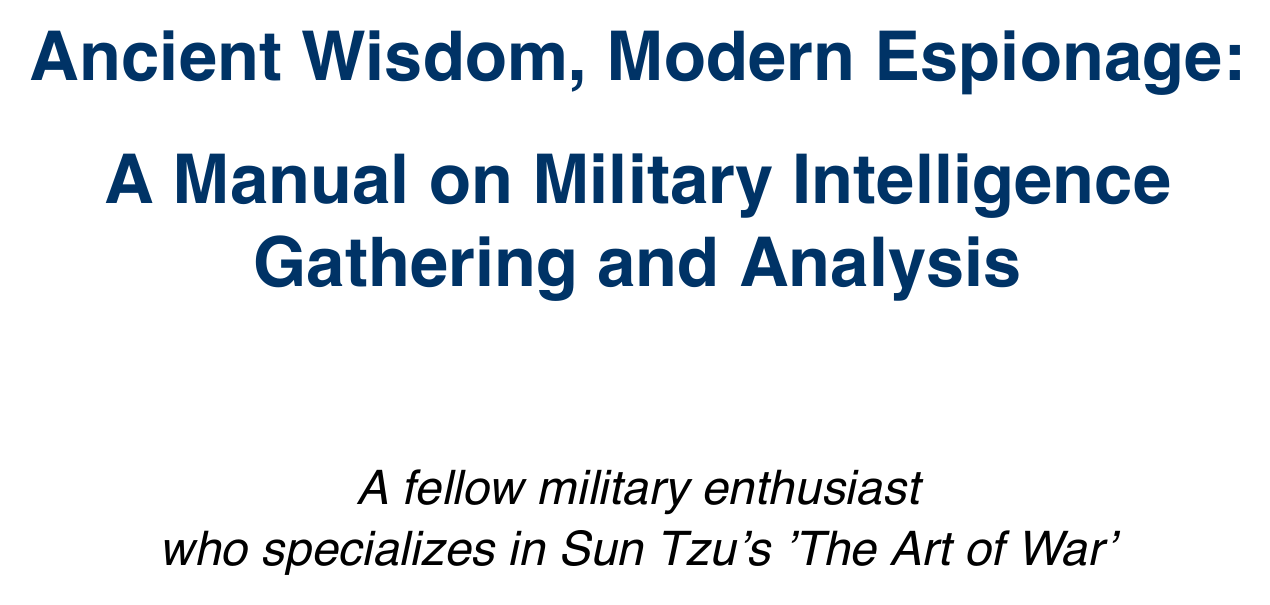What is the title of the manual? The title of the manual is found at the beginning of the document.
Answer: Ancient Wisdom, Modern Espionage: A Manual on Military Intelligence Gathering and Analysis Who is quoted in the introduction? The quote in the introduction is attributed to a famous military strategist.
Answer: Sun Tzu What are the five types of spies mentioned in the manual? The manual refers to the five types of spies listed in 'The Art of War'.
Answer: The Five Types of Spies What historical case study demonstrates deception in World War II? A specific case study is highlighted to show historical espionage tactics.
Answer: Operation Mincemeat Which technology is described as an advanced data analysis platform? The tools and technologies section provides a description of various intelligence tools.
Answer: Palantir Gotham What ethical dilemma is mentioned in relation to modern intelligence gathering? The manual discusses various ethical challenges presented in contemporary espionage.
Answer: Torture What did the British intelligence intercept that led to the US entry into World War I? This event showcases effective intelligence gathering techniques used during a significant conflict.
Answer: The Zimmermann Telegram What is emphasized by Sun Tzu regarding the moral use of spies? The manual explores the ethical considerations presented in relation to intelligence operations.
Answer: Moral use of spies Which ancient method corresponds with modern digital security measures? The text draws parallels between historical and modern techniques in intelligence.
Answer: Detecting and neutralizing spies 